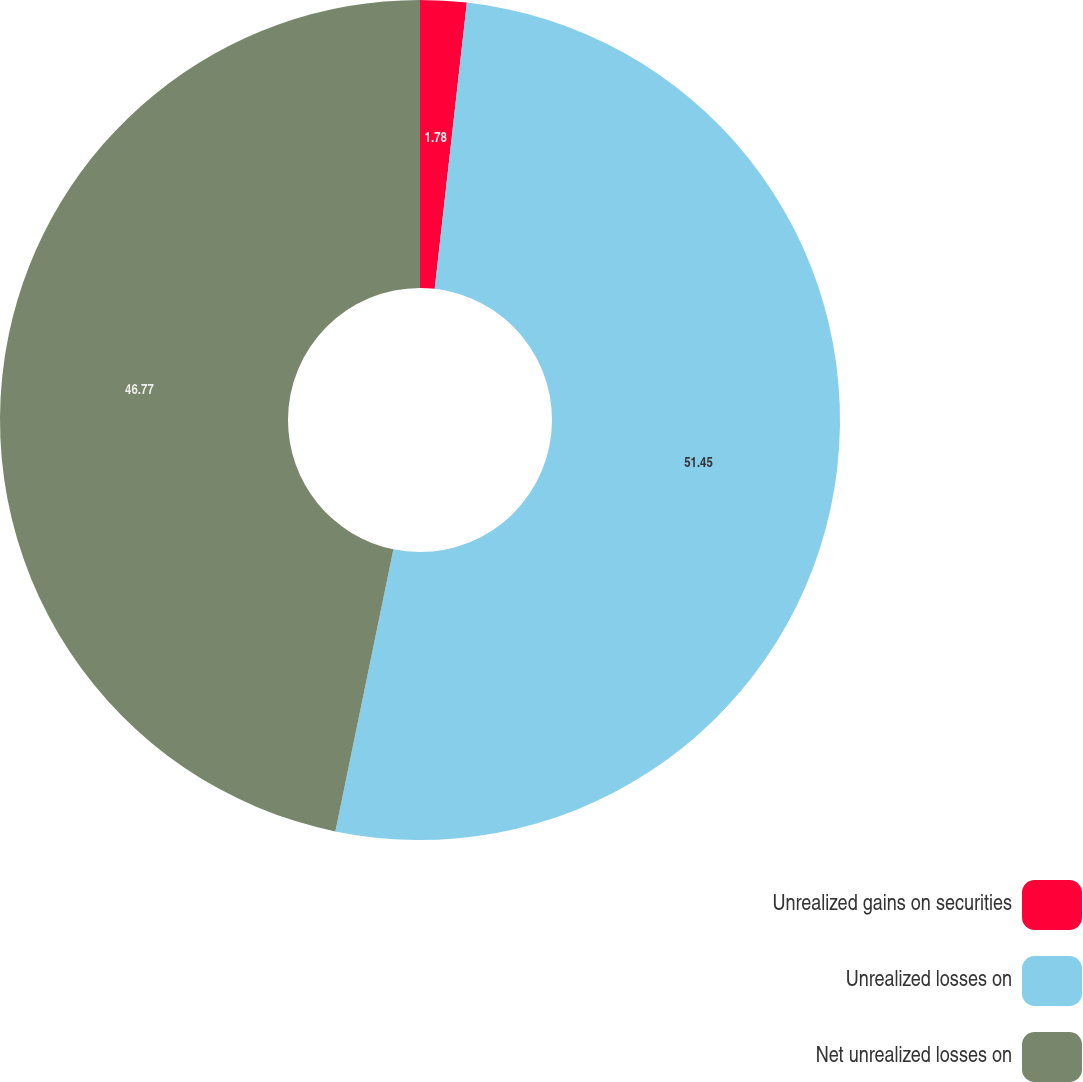<chart> <loc_0><loc_0><loc_500><loc_500><pie_chart><fcel>Unrealized gains on securities<fcel>Unrealized losses on<fcel>Net unrealized losses on<nl><fcel>1.78%<fcel>51.45%<fcel>46.77%<nl></chart> 